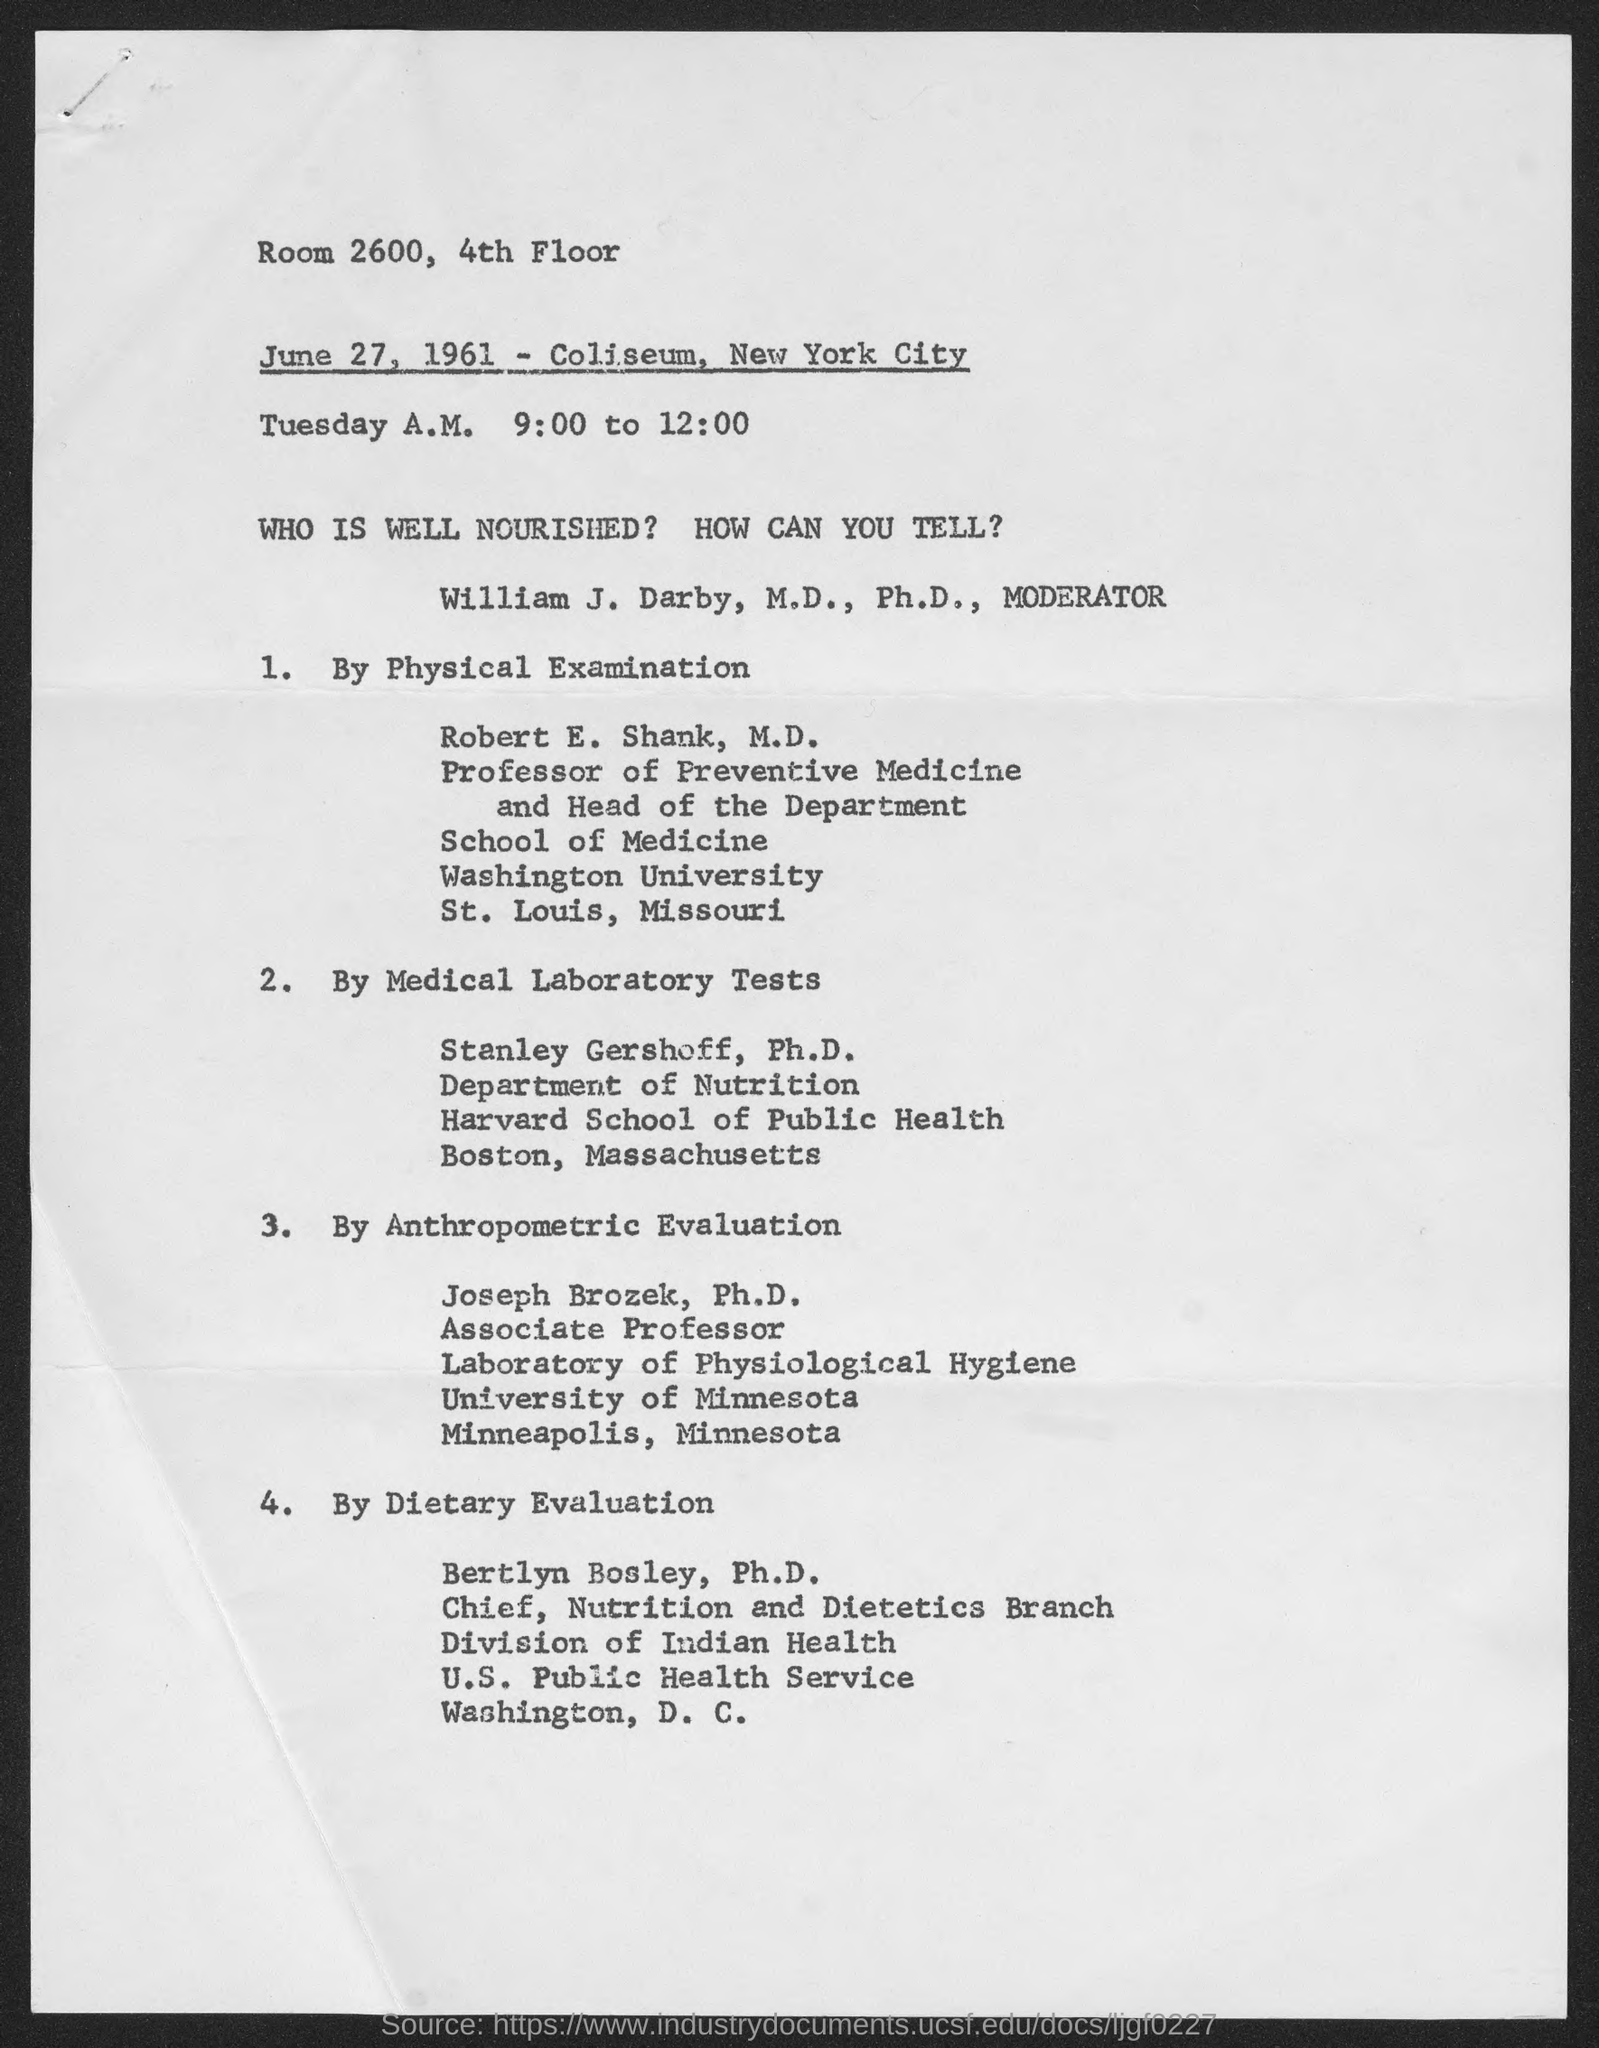Indicate a few pertinent items in this graphic. The document indicates that the date is June 27, 1961. The location of the event is Room 2600 on the 4th Floor. 